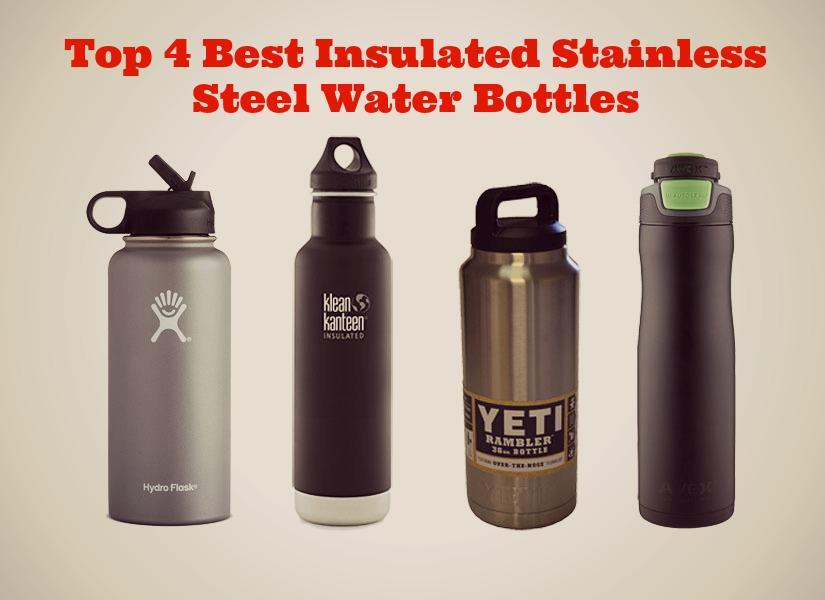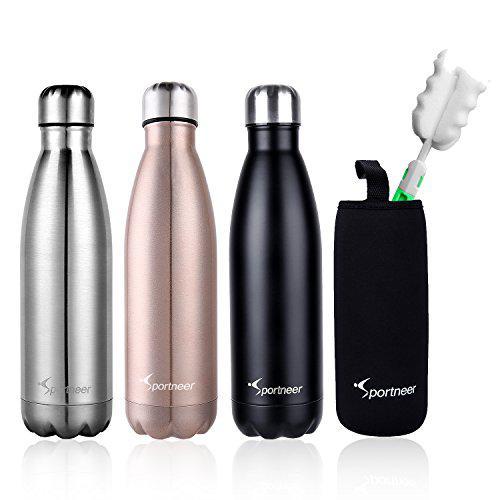The first image is the image on the left, the second image is the image on the right. Examine the images to the left and right. Is the description "There are fifteen bottles in total." accurate? Answer yes or no. No. The first image is the image on the left, the second image is the image on the right. Evaluate the accuracy of this statement regarding the images: "The left and right image contains the same number of rows of stainless steel water bottles.". Is it true? Answer yes or no. Yes. 